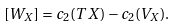<formula> <loc_0><loc_0><loc_500><loc_500>[ W _ { X } ] = c _ { 2 } ( T X ) - c _ { 2 } ( V _ { X } ) .</formula> 